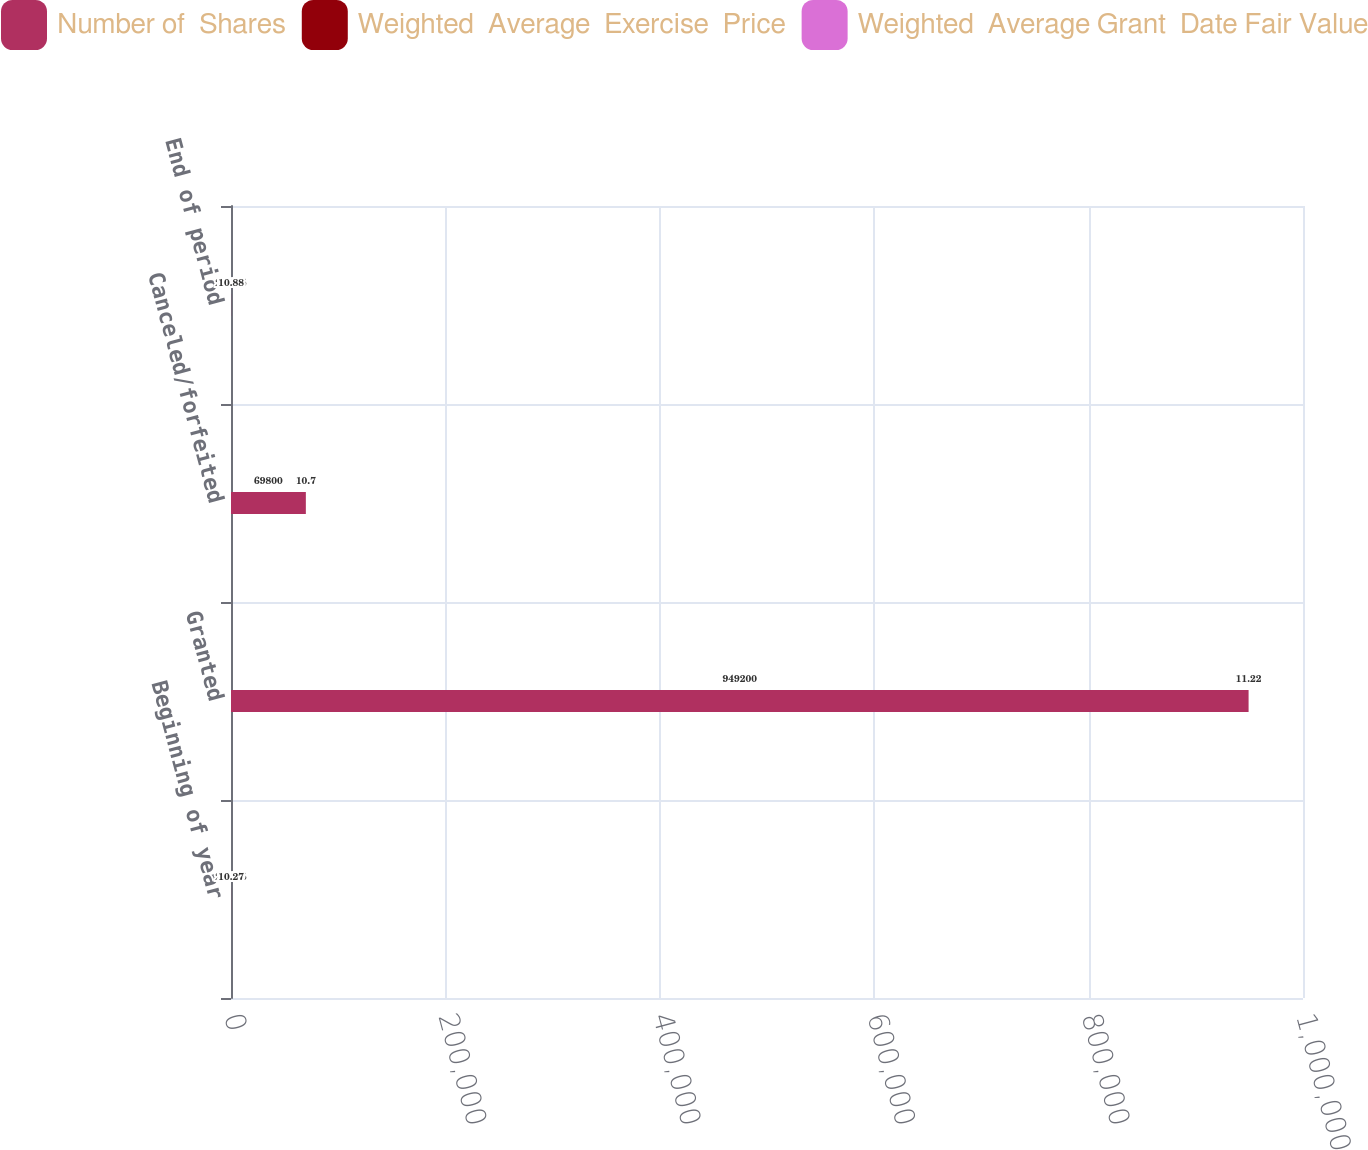<chart> <loc_0><loc_0><loc_500><loc_500><stacked_bar_chart><ecel><fcel>Beginning of year<fcel>Granted<fcel>Canceled/forfeited<fcel>End of period<nl><fcel>Number of  Shares<fcel>29.375<fcel>949200<fcel>69800<fcel>29.375<nl><fcel>Weighted  Average  Exercise  Price<fcel>26.69<fcel>49.32<fcel>44.2<fcel>32.06<nl><fcel>Weighted  Average Grant  Date Fair Value<fcel>10.27<fcel>11.22<fcel>10.7<fcel>10.88<nl></chart> 